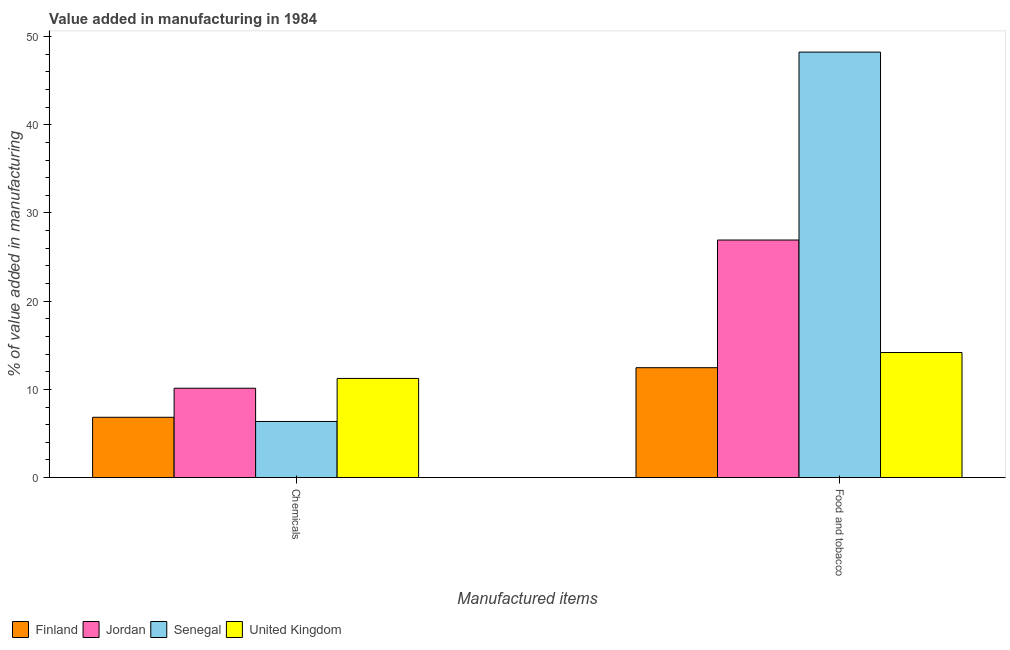How many different coloured bars are there?
Give a very brief answer. 4. How many groups of bars are there?
Give a very brief answer. 2. Are the number of bars on each tick of the X-axis equal?
Give a very brief answer. Yes. How many bars are there on the 2nd tick from the left?
Provide a short and direct response. 4. How many bars are there on the 1st tick from the right?
Keep it short and to the point. 4. What is the label of the 2nd group of bars from the left?
Offer a very short reply. Food and tobacco. What is the value added by  manufacturing chemicals in Jordan?
Offer a terse response. 10.13. Across all countries, what is the maximum value added by manufacturing food and tobacco?
Ensure brevity in your answer.  48.24. Across all countries, what is the minimum value added by manufacturing food and tobacco?
Offer a very short reply. 12.46. In which country was the value added by manufacturing food and tobacco maximum?
Provide a succinct answer. Senegal. In which country was the value added by manufacturing food and tobacco minimum?
Give a very brief answer. Finland. What is the total value added by  manufacturing chemicals in the graph?
Your answer should be very brief. 34.56. What is the difference between the value added by manufacturing food and tobacco in Finland and that in Senegal?
Offer a terse response. -35.79. What is the difference between the value added by manufacturing food and tobacco in Senegal and the value added by  manufacturing chemicals in Finland?
Your response must be concise. 41.41. What is the average value added by manufacturing food and tobacco per country?
Your answer should be very brief. 25.45. What is the difference between the value added by manufacturing food and tobacco and value added by  manufacturing chemicals in Senegal?
Your response must be concise. 41.88. What is the ratio of the value added by  manufacturing chemicals in Jordan to that in Finland?
Your answer should be compact. 1.48. Is the value added by manufacturing food and tobacco in Finland less than that in Jordan?
Your answer should be compact. Yes. What does the 3rd bar from the left in Chemicals represents?
Give a very brief answer. Senegal. What does the 3rd bar from the right in Food and tobacco represents?
Give a very brief answer. Jordan. How many bars are there?
Offer a very short reply. 8. Are all the bars in the graph horizontal?
Your answer should be compact. No. How many countries are there in the graph?
Provide a succinct answer. 4. Where does the legend appear in the graph?
Your answer should be compact. Bottom left. What is the title of the graph?
Provide a succinct answer. Value added in manufacturing in 1984. Does "San Marino" appear as one of the legend labels in the graph?
Your answer should be compact. No. What is the label or title of the X-axis?
Make the answer very short. Manufactured items. What is the label or title of the Y-axis?
Keep it short and to the point. % of value added in manufacturing. What is the % of value added in manufacturing in Finland in Chemicals?
Your answer should be compact. 6.83. What is the % of value added in manufacturing of Jordan in Chemicals?
Provide a succinct answer. 10.13. What is the % of value added in manufacturing of Senegal in Chemicals?
Offer a very short reply. 6.36. What is the % of value added in manufacturing in United Kingdom in Chemicals?
Offer a very short reply. 11.24. What is the % of value added in manufacturing in Finland in Food and tobacco?
Provide a succinct answer. 12.46. What is the % of value added in manufacturing of Jordan in Food and tobacco?
Offer a terse response. 26.93. What is the % of value added in manufacturing in Senegal in Food and tobacco?
Offer a very short reply. 48.24. What is the % of value added in manufacturing of United Kingdom in Food and tobacco?
Provide a short and direct response. 14.18. Across all Manufactured items, what is the maximum % of value added in manufacturing in Finland?
Give a very brief answer. 12.46. Across all Manufactured items, what is the maximum % of value added in manufacturing in Jordan?
Offer a terse response. 26.93. Across all Manufactured items, what is the maximum % of value added in manufacturing in Senegal?
Your answer should be compact. 48.24. Across all Manufactured items, what is the maximum % of value added in manufacturing of United Kingdom?
Ensure brevity in your answer.  14.18. Across all Manufactured items, what is the minimum % of value added in manufacturing of Finland?
Your answer should be very brief. 6.83. Across all Manufactured items, what is the minimum % of value added in manufacturing in Jordan?
Your answer should be very brief. 10.13. Across all Manufactured items, what is the minimum % of value added in manufacturing of Senegal?
Offer a terse response. 6.36. Across all Manufactured items, what is the minimum % of value added in manufacturing of United Kingdom?
Your answer should be very brief. 11.24. What is the total % of value added in manufacturing in Finland in the graph?
Make the answer very short. 19.29. What is the total % of value added in manufacturing of Jordan in the graph?
Offer a terse response. 37.06. What is the total % of value added in manufacturing in Senegal in the graph?
Give a very brief answer. 54.6. What is the total % of value added in manufacturing in United Kingdom in the graph?
Provide a succinct answer. 25.42. What is the difference between the % of value added in manufacturing of Finland in Chemicals and that in Food and tobacco?
Provide a succinct answer. -5.62. What is the difference between the % of value added in manufacturing of Jordan in Chemicals and that in Food and tobacco?
Keep it short and to the point. -16.8. What is the difference between the % of value added in manufacturing in Senegal in Chemicals and that in Food and tobacco?
Your answer should be compact. -41.88. What is the difference between the % of value added in manufacturing in United Kingdom in Chemicals and that in Food and tobacco?
Offer a terse response. -2.94. What is the difference between the % of value added in manufacturing of Finland in Chemicals and the % of value added in manufacturing of Jordan in Food and tobacco?
Provide a succinct answer. -20.1. What is the difference between the % of value added in manufacturing in Finland in Chemicals and the % of value added in manufacturing in Senegal in Food and tobacco?
Offer a very short reply. -41.41. What is the difference between the % of value added in manufacturing of Finland in Chemicals and the % of value added in manufacturing of United Kingdom in Food and tobacco?
Give a very brief answer. -7.34. What is the difference between the % of value added in manufacturing in Jordan in Chemicals and the % of value added in manufacturing in Senegal in Food and tobacco?
Make the answer very short. -38.11. What is the difference between the % of value added in manufacturing of Jordan in Chemicals and the % of value added in manufacturing of United Kingdom in Food and tobacco?
Offer a very short reply. -4.05. What is the difference between the % of value added in manufacturing of Senegal in Chemicals and the % of value added in manufacturing of United Kingdom in Food and tobacco?
Provide a succinct answer. -7.82. What is the average % of value added in manufacturing in Finland per Manufactured items?
Offer a very short reply. 9.65. What is the average % of value added in manufacturing in Jordan per Manufactured items?
Give a very brief answer. 18.53. What is the average % of value added in manufacturing in Senegal per Manufactured items?
Offer a terse response. 27.3. What is the average % of value added in manufacturing in United Kingdom per Manufactured items?
Keep it short and to the point. 12.71. What is the difference between the % of value added in manufacturing in Finland and % of value added in manufacturing in Jordan in Chemicals?
Give a very brief answer. -3.3. What is the difference between the % of value added in manufacturing of Finland and % of value added in manufacturing of Senegal in Chemicals?
Offer a terse response. 0.48. What is the difference between the % of value added in manufacturing of Finland and % of value added in manufacturing of United Kingdom in Chemicals?
Offer a very short reply. -4.4. What is the difference between the % of value added in manufacturing of Jordan and % of value added in manufacturing of Senegal in Chemicals?
Give a very brief answer. 3.77. What is the difference between the % of value added in manufacturing of Jordan and % of value added in manufacturing of United Kingdom in Chemicals?
Give a very brief answer. -1.11. What is the difference between the % of value added in manufacturing in Senegal and % of value added in manufacturing in United Kingdom in Chemicals?
Keep it short and to the point. -4.88. What is the difference between the % of value added in manufacturing in Finland and % of value added in manufacturing in Jordan in Food and tobacco?
Provide a succinct answer. -14.48. What is the difference between the % of value added in manufacturing of Finland and % of value added in manufacturing of Senegal in Food and tobacco?
Provide a short and direct response. -35.79. What is the difference between the % of value added in manufacturing in Finland and % of value added in manufacturing in United Kingdom in Food and tobacco?
Your response must be concise. -1.72. What is the difference between the % of value added in manufacturing in Jordan and % of value added in manufacturing in Senegal in Food and tobacco?
Make the answer very short. -21.31. What is the difference between the % of value added in manufacturing of Jordan and % of value added in manufacturing of United Kingdom in Food and tobacco?
Make the answer very short. 12.76. What is the difference between the % of value added in manufacturing of Senegal and % of value added in manufacturing of United Kingdom in Food and tobacco?
Give a very brief answer. 34.06. What is the ratio of the % of value added in manufacturing in Finland in Chemicals to that in Food and tobacco?
Offer a very short reply. 0.55. What is the ratio of the % of value added in manufacturing of Jordan in Chemicals to that in Food and tobacco?
Provide a succinct answer. 0.38. What is the ratio of the % of value added in manufacturing in Senegal in Chemicals to that in Food and tobacco?
Your answer should be very brief. 0.13. What is the ratio of the % of value added in manufacturing in United Kingdom in Chemicals to that in Food and tobacco?
Offer a very short reply. 0.79. What is the difference between the highest and the second highest % of value added in manufacturing in Finland?
Make the answer very short. 5.62. What is the difference between the highest and the second highest % of value added in manufacturing in Jordan?
Your response must be concise. 16.8. What is the difference between the highest and the second highest % of value added in manufacturing in Senegal?
Offer a very short reply. 41.88. What is the difference between the highest and the second highest % of value added in manufacturing of United Kingdom?
Offer a very short reply. 2.94. What is the difference between the highest and the lowest % of value added in manufacturing in Finland?
Ensure brevity in your answer.  5.62. What is the difference between the highest and the lowest % of value added in manufacturing in Jordan?
Ensure brevity in your answer.  16.8. What is the difference between the highest and the lowest % of value added in manufacturing in Senegal?
Your response must be concise. 41.88. What is the difference between the highest and the lowest % of value added in manufacturing of United Kingdom?
Ensure brevity in your answer.  2.94. 